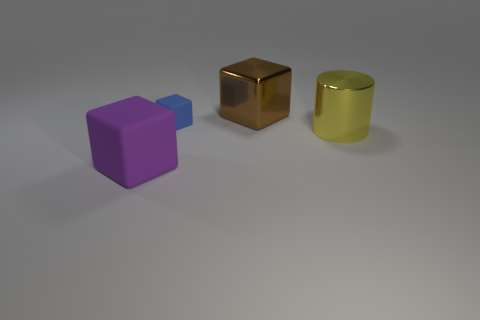Add 3 purple things. How many objects exist? 7 Subtract all cylinders. How many objects are left? 3 Subtract all large purple matte things. Subtract all big yellow balls. How many objects are left? 3 Add 2 big yellow metallic cylinders. How many big yellow metallic cylinders are left? 3 Add 4 tiny green matte cubes. How many tiny green matte cubes exist? 4 Subtract 0 yellow spheres. How many objects are left? 4 